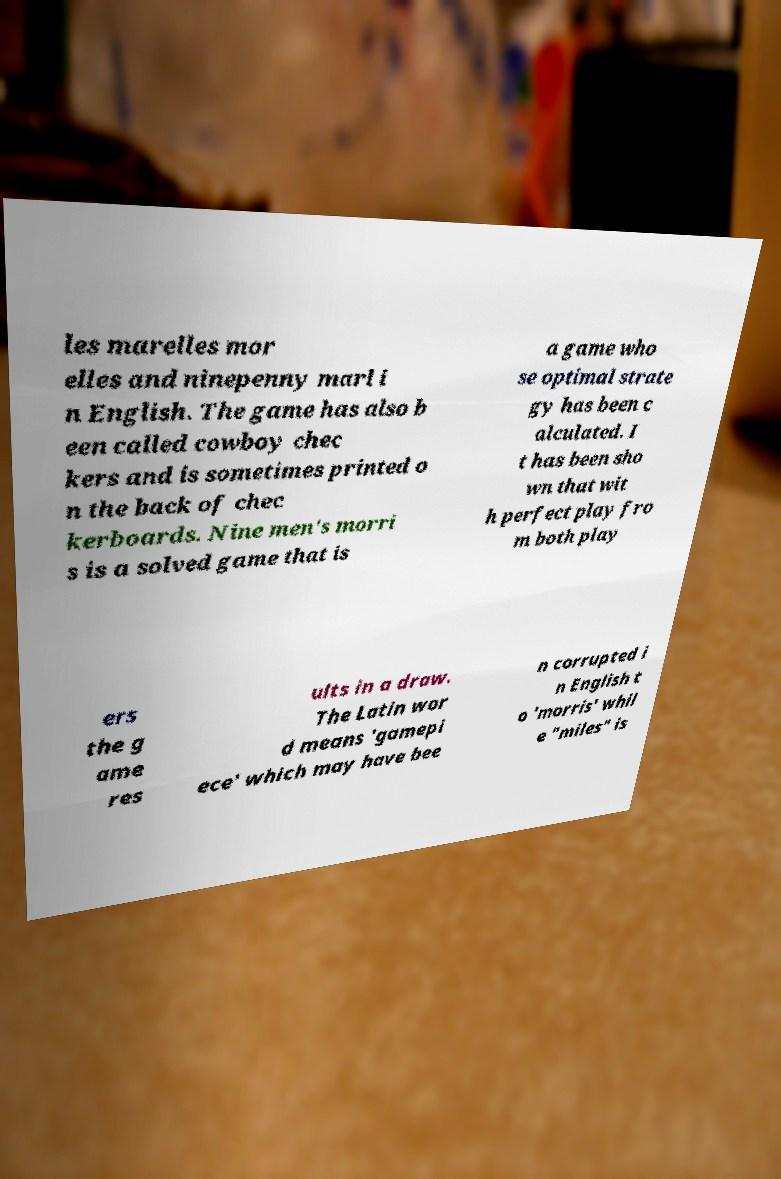I need the written content from this picture converted into text. Can you do that? les marelles mor elles and ninepenny marl i n English. The game has also b een called cowboy chec kers and is sometimes printed o n the back of chec kerboards. Nine men's morri s is a solved game that is a game who se optimal strate gy has been c alculated. I t has been sho wn that wit h perfect play fro m both play ers the g ame res ults in a draw. The Latin wor d means 'gamepi ece' which may have bee n corrupted i n English t o 'morris' whil e "miles" is 